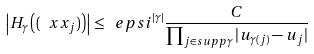<formula> <loc_0><loc_0><loc_500><loc_500>\left | H _ { \gamma } \left ( ( \ x x _ { j } ) \right ) \right | \leq \ e p s i ^ { | \gamma | } \frac { C } { \prod _ { j \in s u p p \gamma } | u _ { \gamma ( j ) } - u _ { j } | }</formula> 